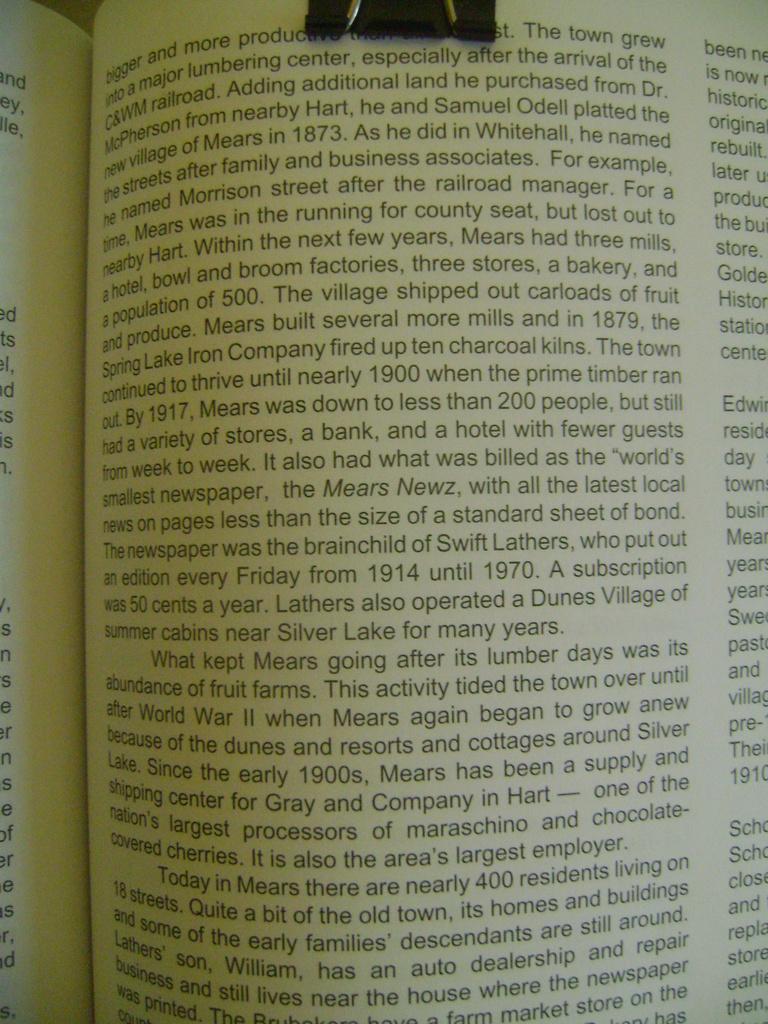What is the first word?
Give a very brief answer. Bigger. What is the first word of the third paragraph?
Provide a succinct answer. Today. 